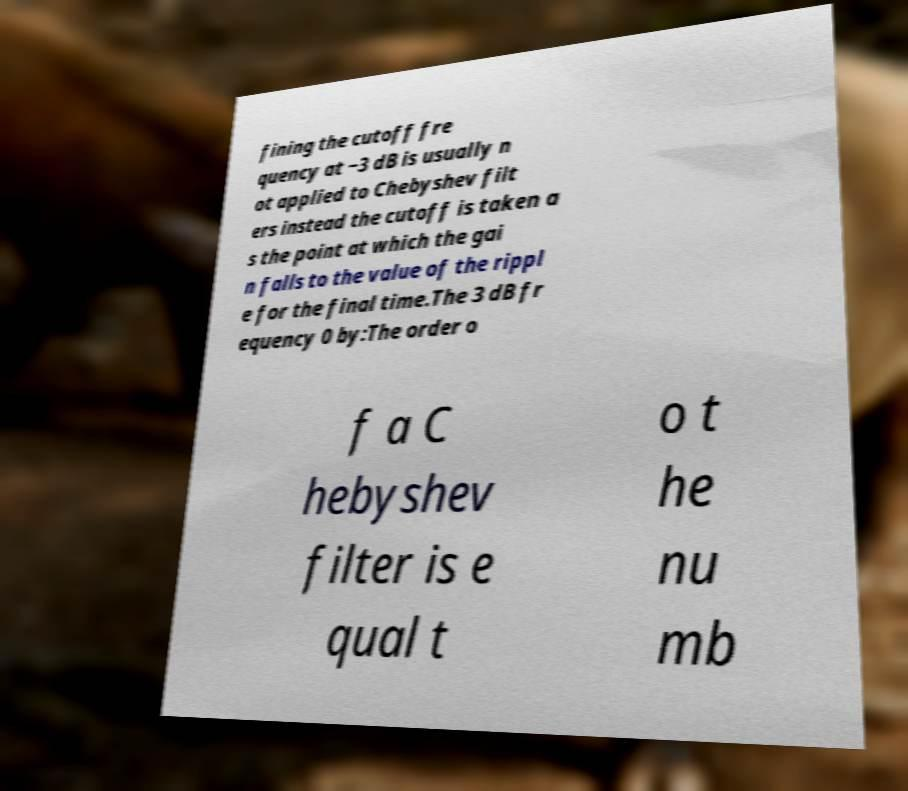Could you assist in decoding the text presented in this image and type it out clearly? fining the cutoff fre quency at −3 dB is usually n ot applied to Chebyshev filt ers instead the cutoff is taken a s the point at which the gai n falls to the value of the rippl e for the final time.The 3 dB fr equency 0 by:The order o f a C hebyshev filter is e qual t o t he nu mb 